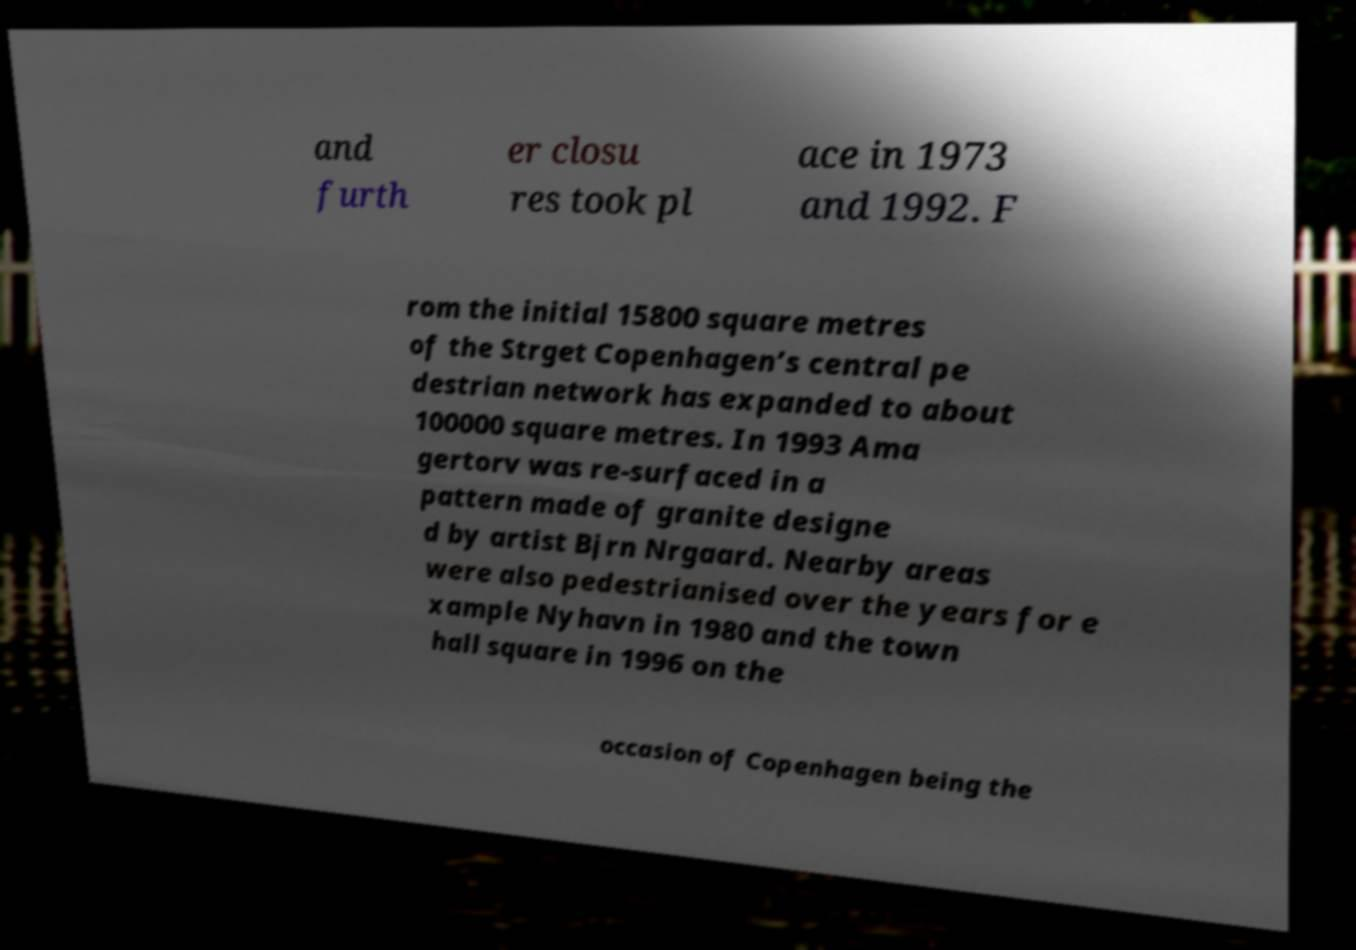I need the written content from this picture converted into text. Can you do that? and furth er closu res took pl ace in 1973 and 1992. F rom the initial 15800 square metres of the Strget Copenhagen’s central pe destrian network has expanded to about 100000 square metres. In 1993 Ama gertorv was re-surfaced in a pattern made of granite designe d by artist Bjrn Nrgaard. Nearby areas were also pedestrianised over the years for e xample Nyhavn in 1980 and the town hall square in 1996 on the occasion of Copenhagen being the 